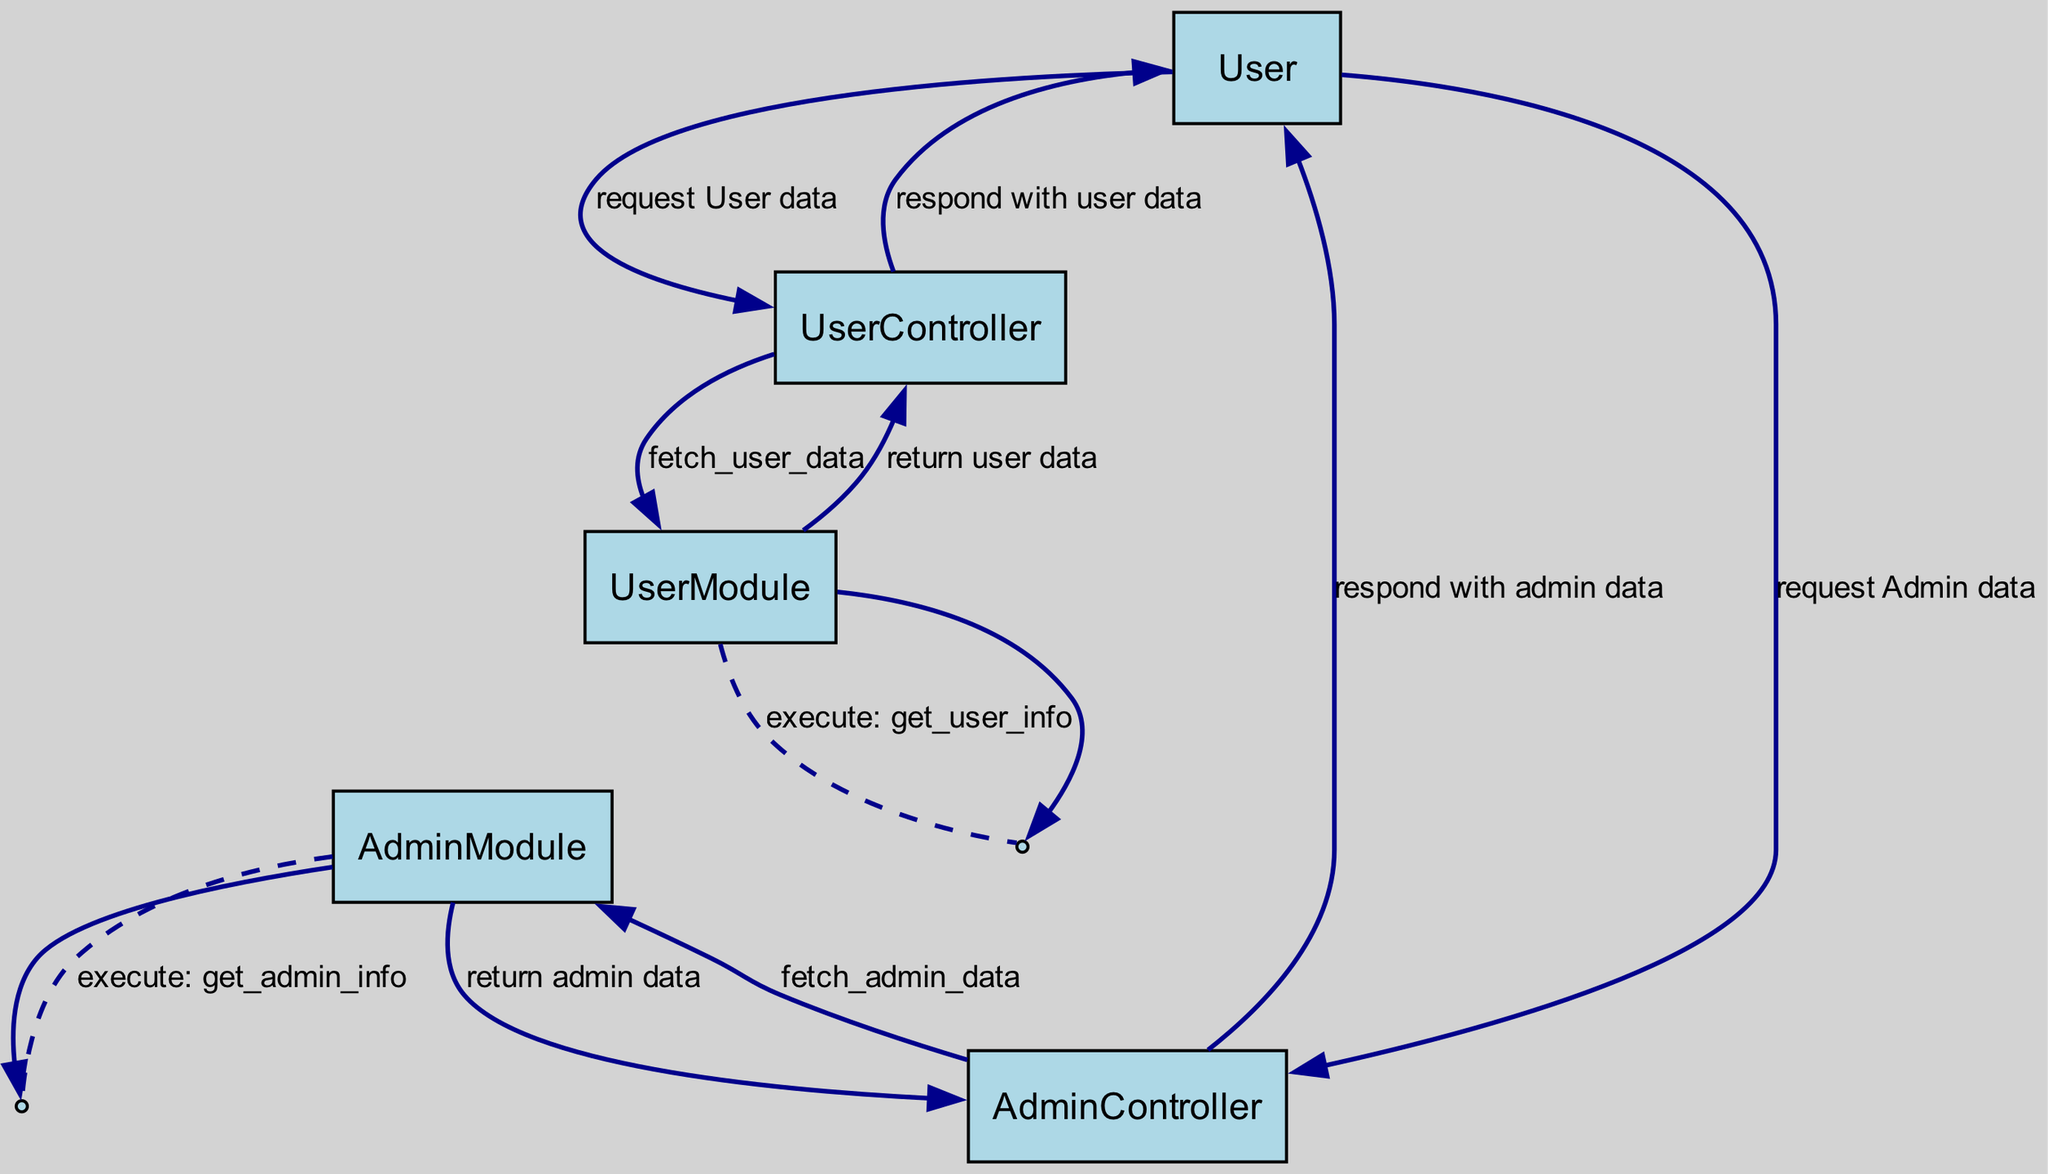What is the first action taken by the User? The first action taken by the User is to request User data. This is represented in the diagram as a message from the User to the UserController.
Answer: request User data How many participants are in the diagram? The diagram has five participants: User, UserController, AdminController, UserModule, and AdminModule. The total is counted by listing all unique actors in the sequence.
Answer: five Which module is responsible for fetching the User data? The UserModule is responsible for fetching User data as shown in the message sequence from UserController to UserModule labeled 'fetch_user_data'.
Answer: UserModule What does AdminController do after fetching Admin data? The AdminController responds with admin data after receiving it from AdminModule. This is indicated in the message flow from AdminModule to AdminController and then to User.
Answer: respond with admin data Which method does UserModule execute to get User information? UserModule executes the method 'get_user_info' to obtain User information as illustrated by the self-message from UserModule to itself labeled 'execute: get_user_info'.
Answer: get_user_info How many messages are sent from User to UserController? The diagram shows one message sent from User to UserController, which is the request for User data. Count the arrows directed from User to UserController to confirm.
Answer: one What happens after the UserModule returns user data? After returning user data, the UserController responds to the User with that data. This flow is shown in the sequence where UserModule returns user data to UserController, which then sends a response to the User.
Answer: respond with user data In which order are the Admin and User actions performed in the diagram? The diagram shows that the User actions occur first followed by the Admin actions. Specifically, User requests data before the Admin requests data, establishing a clear sequence.
Answer: User actions first What is the relationship between UserController and UserModule? UserController depends on UserModule to fetch User data. The arrows direct from UserController to UserModule, indicating that UserController calls methods defined in UserModule.
Answer: UserController depends on UserModule 